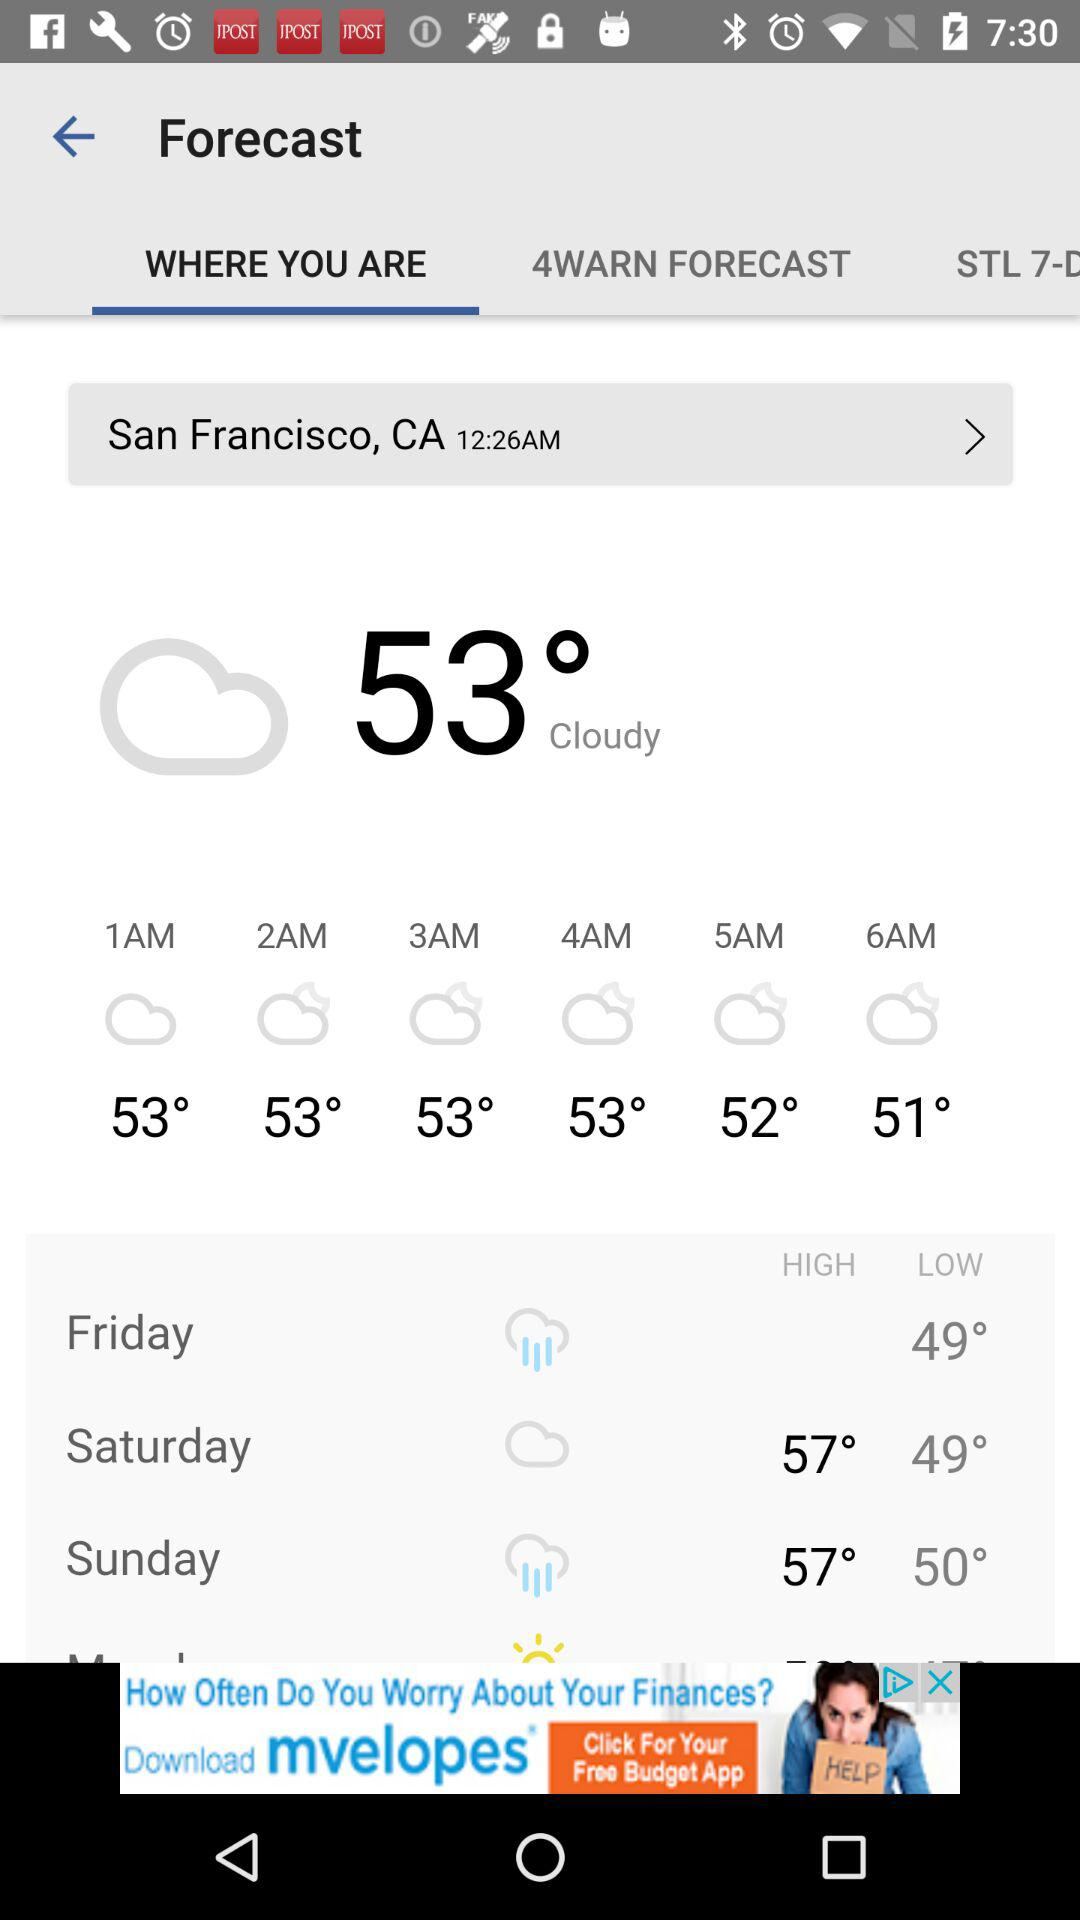Which tab is selected? The selected tab is "WHERE YOU ARE". 